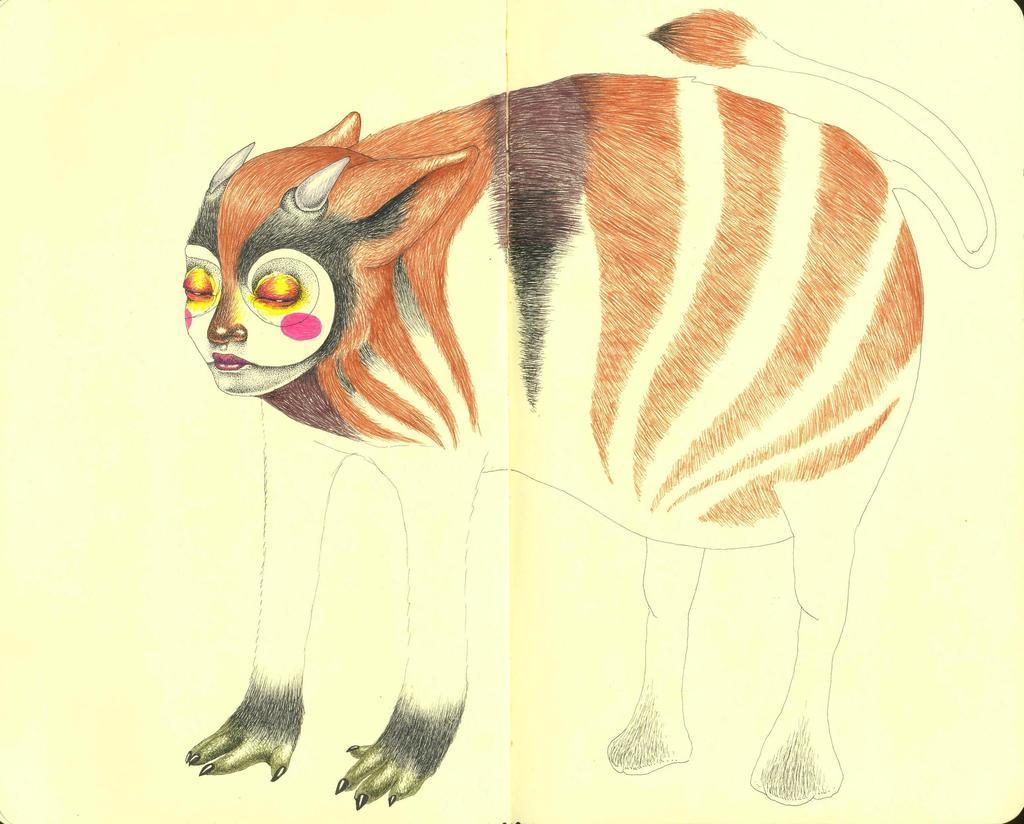How would you summarize this image in a sentence or two? This is a paper and here we can see a sketch of an animal. 